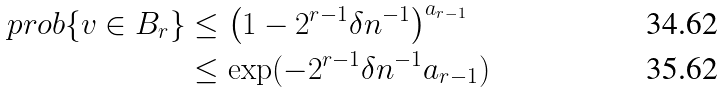<formula> <loc_0><loc_0><loc_500><loc_500>\ p r o b \{ v \in B _ { r } \} & \leq \left ( 1 - 2 ^ { r - 1 } \delta n ^ { - 1 } \right ) ^ { a _ { r - 1 } } \\ & \leq \exp ( - 2 ^ { r - 1 } \delta n ^ { - 1 } a _ { r - 1 } )</formula> 